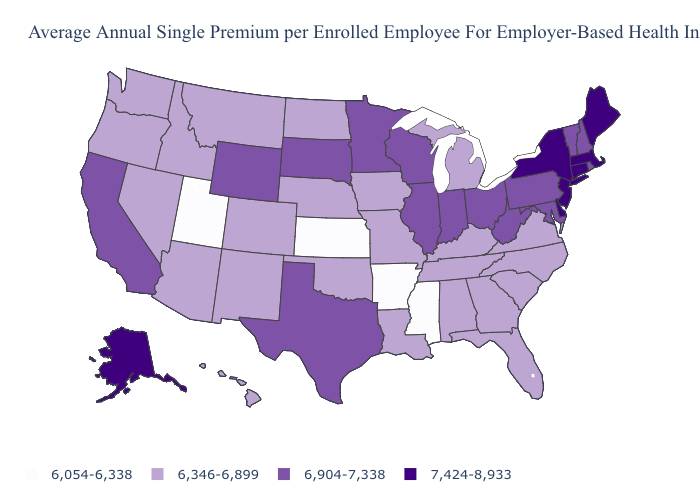Name the states that have a value in the range 6,904-7,338?
Short answer required. California, Illinois, Indiana, Maryland, Minnesota, New Hampshire, Ohio, Pennsylvania, Rhode Island, South Dakota, Texas, Vermont, West Virginia, Wisconsin, Wyoming. Name the states that have a value in the range 6,346-6,899?
Short answer required. Alabama, Arizona, Colorado, Florida, Georgia, Hawaii, Idaho, Iowa, Kentucky, Louisiana, Michigan, Missouri, Montana, Nebraska, Nevada, New Mexico, North Carolina, North Dakota, Oklahoma, Oregon, South Carolina, Tennessee, Virginia, Washington. Among the states that border Oregon , does Idaho have the lowest value?
Quick response, please. Yes. Name the states that have a value in the range 6,054-6,338?
Quick response, please. Arkansas, Kansas, Mississippi, Utah. Name the states that have a value in the range 6,904-7,338?
Write a very short answer. California, Illinois, Indiana, Maryland, Minnesota, New Hampshire, Ohio, Pennsylvania, Rhode Island, South Dakota, Texas, Vermont, West Virginia, Wisconsin, Wyoming. Among the states that border Alabama , which have the lowest value?
Be succinct. Mississippi. Does Iowa have the same value as Oklahoma?
Write a very short answer. Yes. What is the value of New York?
Write a very short answer. 7,424-8,933. Name the states that have a value in the range 6,346-6,899?
Give a very brief answer. Alabama, Arizona, Colorado, Florida, Georgia, Hawaii, Idaho, Iowa, Kentucky, Louisiana, Michigan, Missouri, Montana, Nebraska, Nevada, New Mexico, North Carolina, North Dakota, Oklahoma, Oregon, South Carolina, Tennessee, Virginia, Washington. What is the value of Texas?
Quick response, please. 6,904-7,338. What is the value of Connecticut?
Keep it brief. 7,424-8,933. Does New Hampshire have a lower value than Connecticut?
Quick response, please. Yes. Name the states that have a value in the range 7,424-8,933?
Short answer required. Alaska, Connecticut, Delaware, Maine, Massachusetts, New Jersey, New York. What is the lowest value in states that border Louisiana?
Answer briefly. 6,054-6,338. 